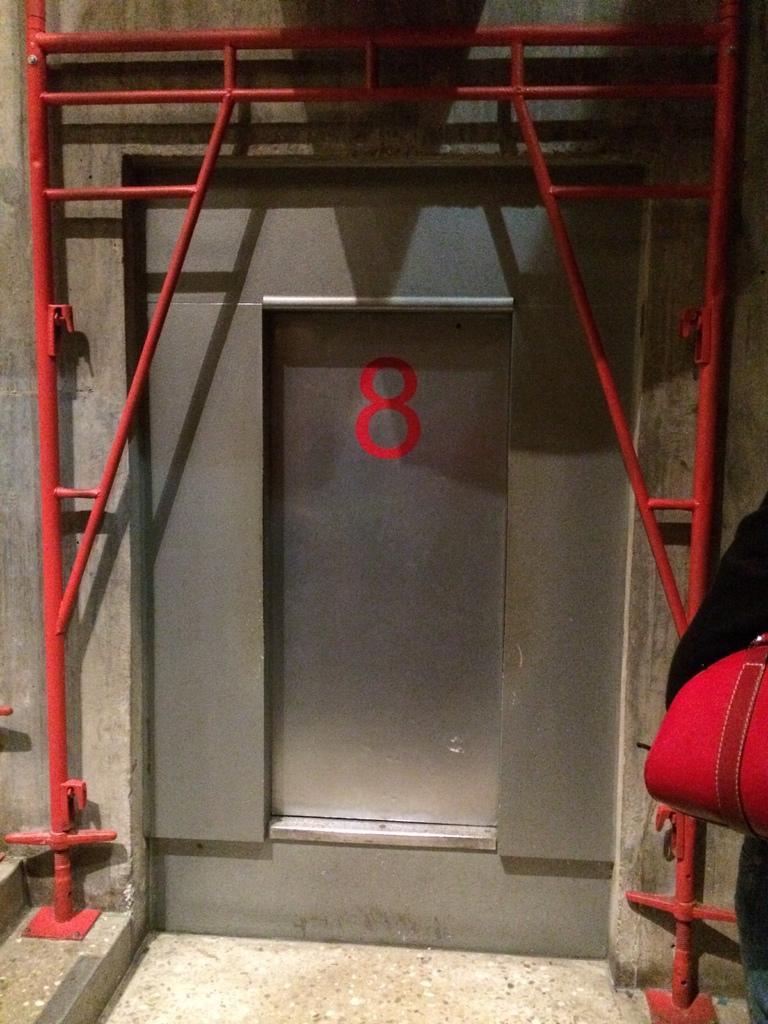How would you summarize this image in a sentence or two? In the foreground of this image, on the right, there is a person wearing a red color bag. In the middle, it seems like there is a steel door and few red rod like structure. 